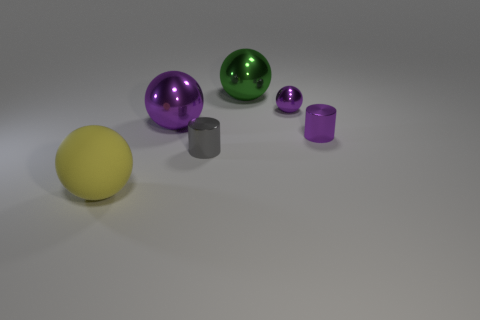Subtract all metal balls. How many balls are left? 1 Subtract all red cubes. How many purple spheres are left? 2 Add 4 large green metal objects. How many objects exist? 10 Subtract all yellow spheres. How many spheres are left? 3 Subtract all cylinders. How many objects are left? 4 Subtract all yellow balls. Subtract all purple cubes. How many balls are left? 3 Subtract all tiny purple matte cylinders. Subtract all large yellow things. How many objects are left? 5 Add 2 big green metallic spheres. How many big green metallic spheres are left? 3 Add 4 large matte objects. How many large matte objects exist? 5 Subtract 1 purple cylinders. How many objects are left? 5 